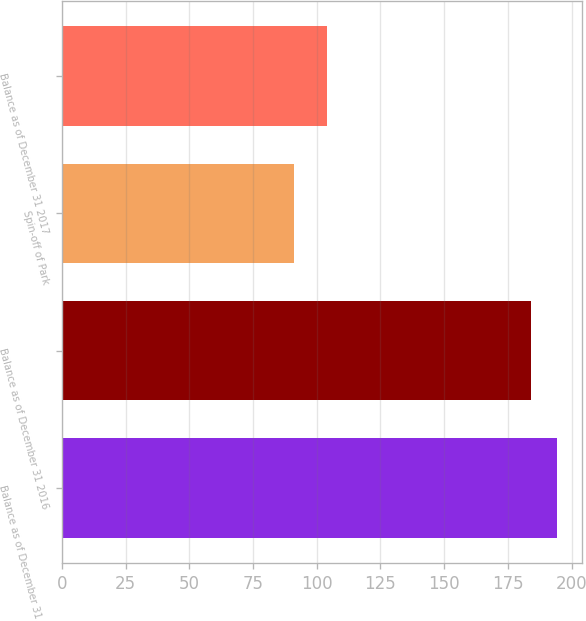<chart> <loc_0><loc_0><loc_500><loc_500><bar_chart><fcel>Balance as of December 31 2015<fcel>Balance as of December 31 2016<fcel>Spin-off of Park<fcel>Balance as of December 31 2017<nl><fcel>194.2<fcel>184<fcel>91<fcel>104<nl></chart> 